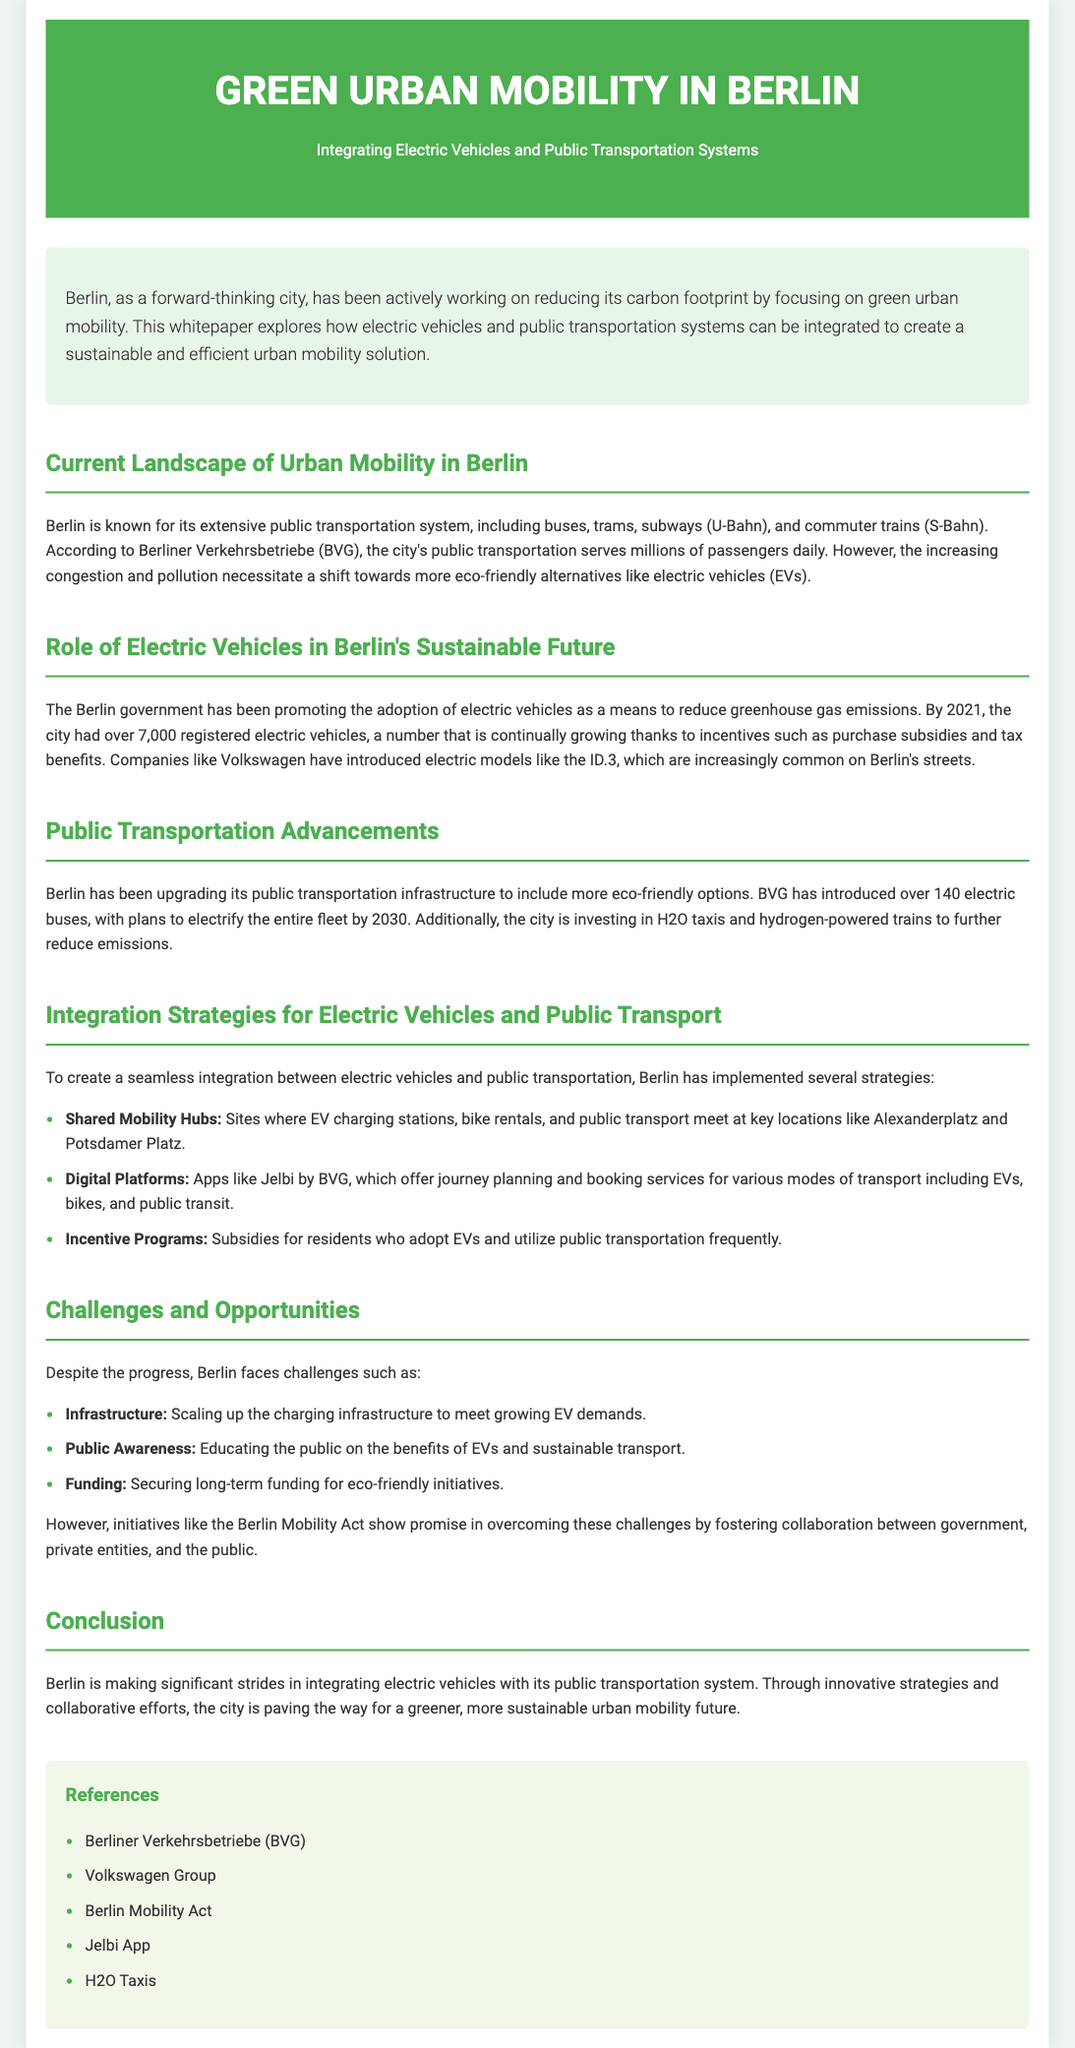what is the primary focus of the whitepaper? The primary focus of the whitepaper is on integrating electric vehicles and public transportation systems for sustainable urban mobility.
Answer: integrating electric vehicles and public transportation systems how many registered electric vehicles were in Berlin by 2021? The document states that by 2021, Berlin had over 7,000 registered electric vehicles.
Answer: over 7,000 what year does Berlin plan to electrify its entire bus fleet? The document mentions that Berlin plans to electrify its entire bus fleet by 2030.
Answer: 2030 name one app mentioned for journey planning in Berlin. The whitepaper refers to the Jelbi app, which offers journey planning and booking services.
Answer: Jelbi what is one challenge facing the integration of electric vehicles in Berlin? The document indicates that scaling up the charging infrastructure is one challenge facing the integration.
Answer: Infrastructure what is the name of the act that fosters collaboration for eco-friendly initiatives? The Berlin Mobility Act is mentioned in the document as a key initiative for collaboration.
Answer: Berlin Mobility Act how many electric buses has BVG introduced? According to the document, BVG has introduced over 140 electric buses.
Answer: over 140 what is a key feature of the shared mobility hubs? Shared mobility hubs include sites where EV charging stations and public transport meet.
Answer: EV charging stations and public transport meet how does the whitepaper classify the document type? The document type is classified as a whitepaper focusing on urban mobility and sustainability.
Answer: whitepaper 